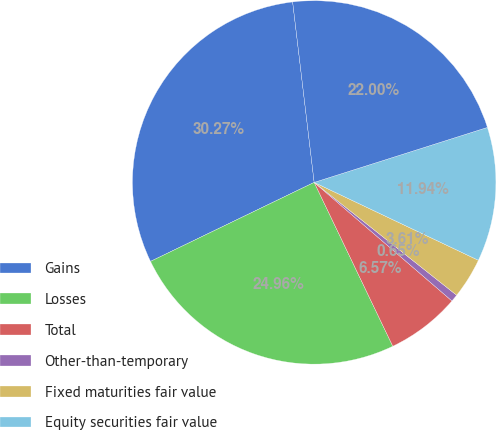Convert chart to OTSL. <chart><loc_0><loc_0><loc_500><loc_500><pie_chart><fcel>Gains<fcel>Losses<fcel>Total<fcel>Other-than-temporary<fcel>Fixed maturities fair value<fcel>Equity securities fair value<fcel>Total net realized capital<nl><fcel>30.27%<fcel>24.96%<fcel>6.57%<fcel>0.65%<fcel>3.61%<fcel>11.94%<fcel>22.0%<nl></chart> 